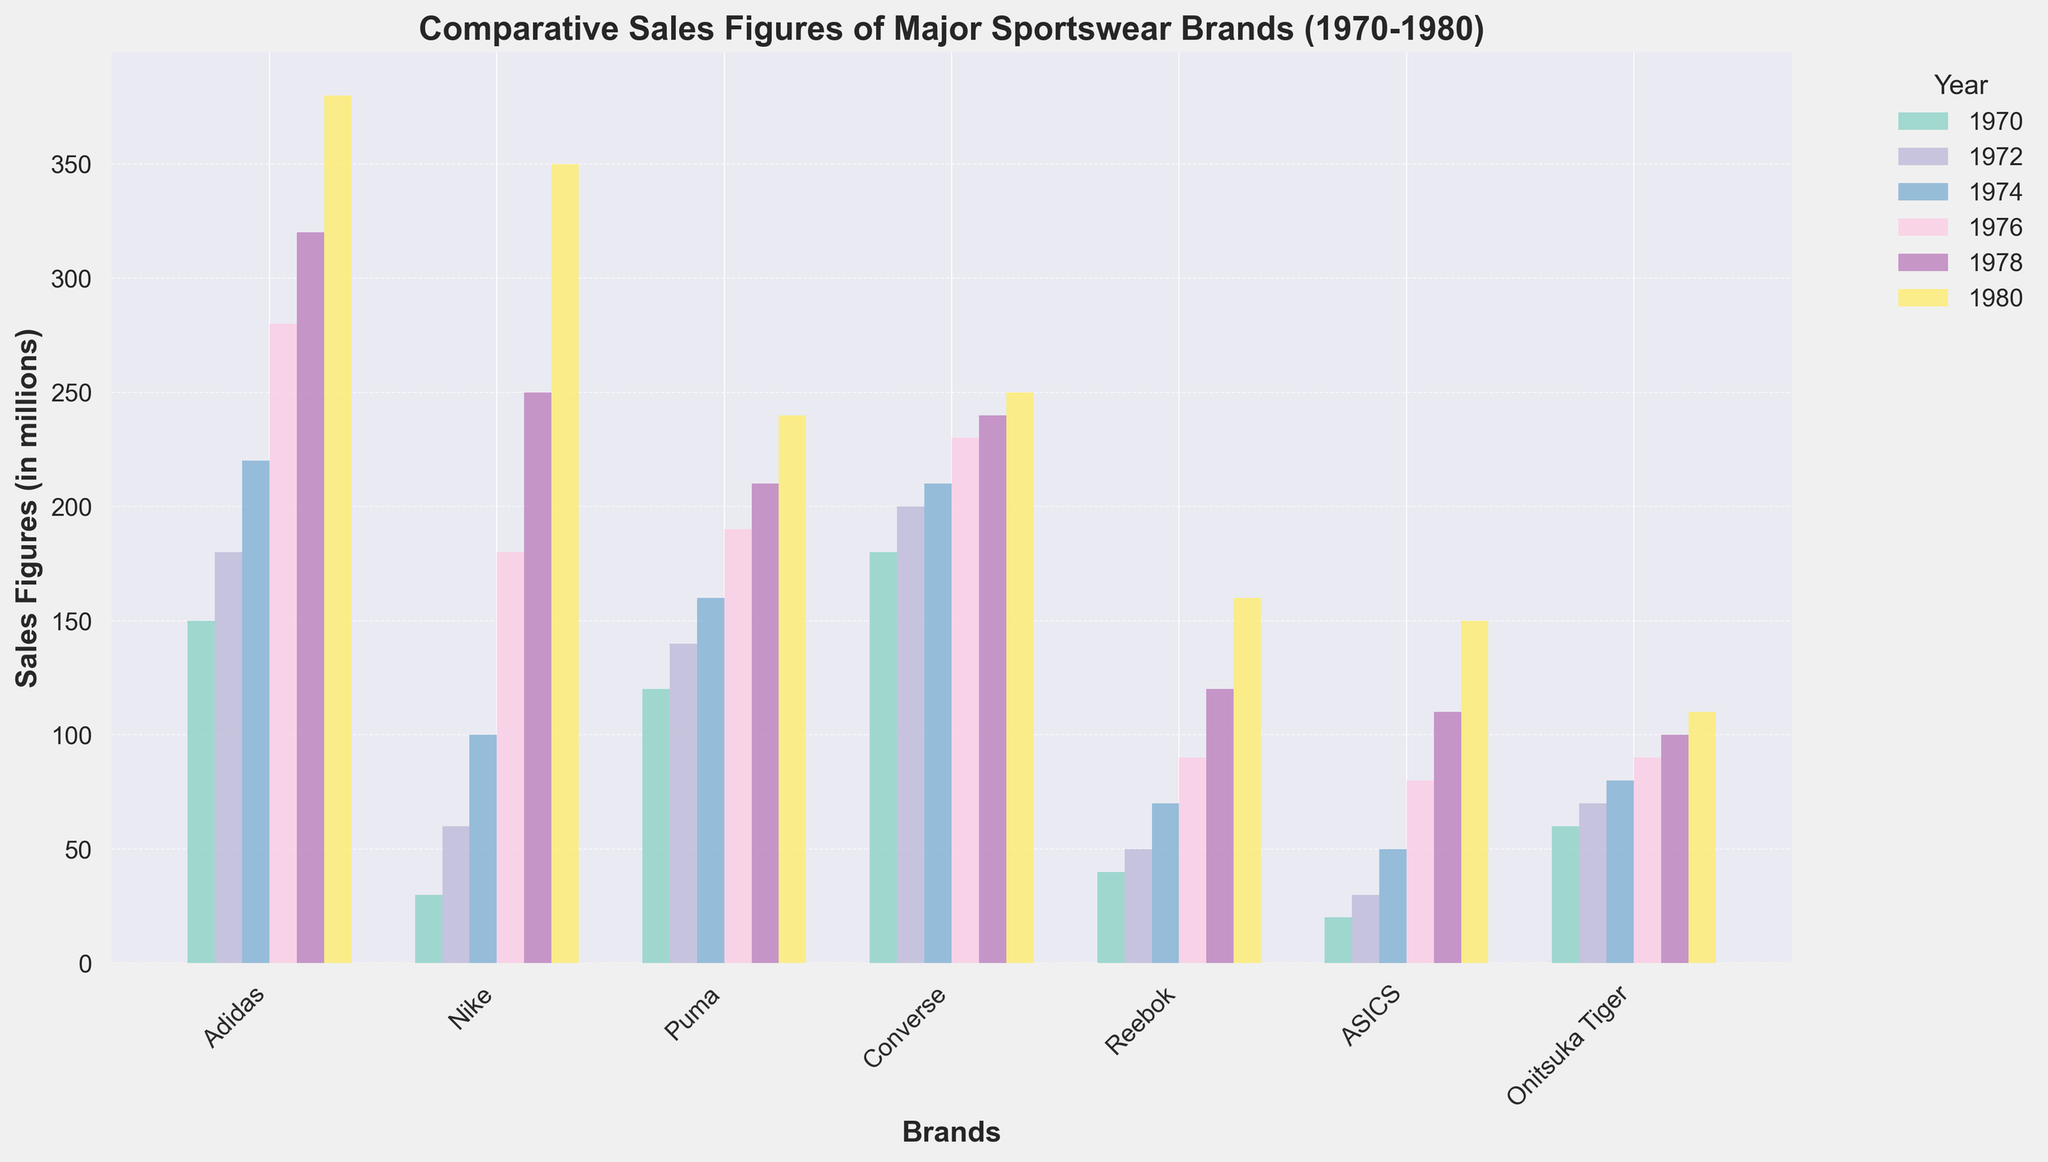What's the highest sales figure for Adidas in the given period? The bar representing Adidas in 1980 is the tallest among the bars for Adidas. The sales figure for Adidas in 1980 is the highest value.
Answer: 380 Which brand had the lowest sales in 1970? By comparing the heights of the bars for each brand in 1970, it's clear that ASICS had the shortest bar, representing the lowest sales.
Answer: ASICS How did Nike's sales change from 1976 to 1980? The sales for Nike in 1976 were represented by a bar at 180, while in 1980, the bar for Nike is at 350. The change can be calculated by subtracting the 1976 sales from the 1980 sales (350 - 180).
Answer: Increase by 170 Between Converse and Puma, which brand had more consistent sales growth from 1970 to 1980? Converse's bars show a relatively even growth pattern from 180 to 250, while Puma's bars show a smaller and somewhat uneven growth from 120 to 240. Converse had a more consistent growth pattern.
Answer: Converse What was the total sales figure for Reebok over the decade? Adding the heights of all the bars for Reebok across the given years: 40 + 50 + 70 + 90 + 120 + 160 results in a total sum of 530.
Answer: 530 In 1980, which two brands had the closest sales figures? By evaluating the heights of the bars for each brand in 1980, ASICS and Onitsuka Tiger have bars of similar height, indicating that their sales values are close at 150 and 110, respectively.
Answer: ASICS and Onitsuka Tiger What's the average sales figure for ASICS during 1970-1980? The sales figures for ASICS over the years are 20, 30, 50, 80, 110, and 150. Summing these up: 20 + 30 + 50 + 80 + 110 + 150 = 440. Dividing by the number of years (6), the average is 440/6.
Answer: 73.33 Which brand showed the largest increase in sales from 1970 to 1980? Comparing the differences between the sales figures in 1980 and 1970 for each brand, Nike's increase is the largest, from 30 to 350, a difference of 320.
Answer: Nike Comparing the sales of Adidas and Reebok, which year was the difference between their sales the highest? Subtracting the sales figures of Reebok from Adidas for each year: (150-40), (180-50), (220-70), (280-90), (320-120), (380-160), the largest difference occurs in 1980, equal to 220.
Answer: 1980 If we average the sales figures of all brands in 1978, what would it be? Summing the sales figures of all brands in 1978: 320 + 250 + 210 + 240 + 120 + 110 + 100 = 1350. Dividing by the number of brands (7), the average is 1350/7.
Answer: 192.86 